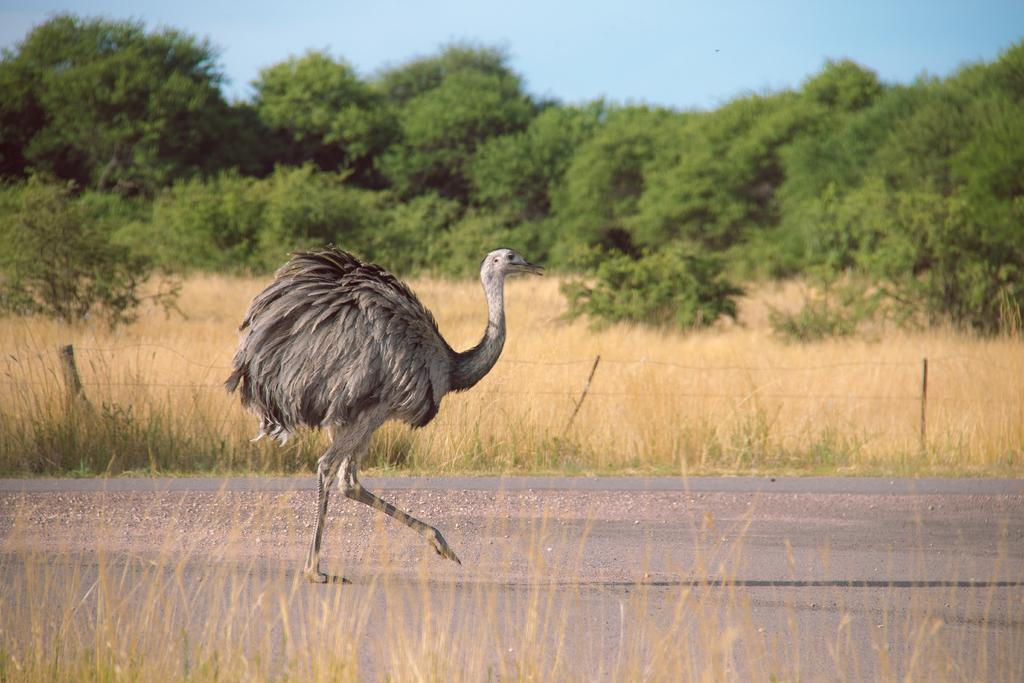Where was the image taken? The image is clicked outside the city. What is the main subject of the image? There is an ostrich in the center of the image. What is the ostrich doing in the image? The ostrich is walking on the ground. What can be seen in the background of the image? There is a sky, trees, plants, and dry grass visible in the background of the image. What type of music can be heard playing in the background of the image? There is no music present in the image, as it is a photograph and cannot contain audible elements. 